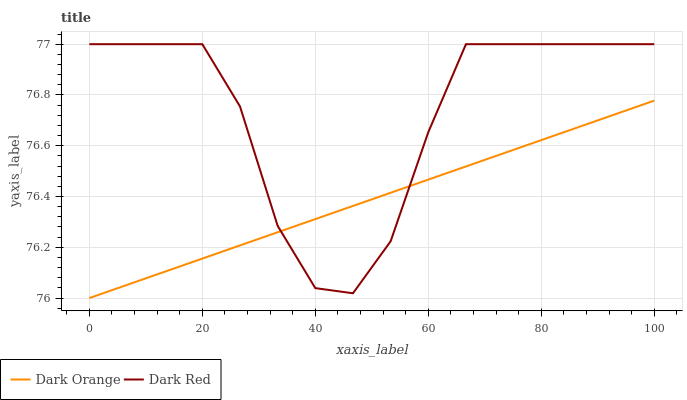Does Dark Orange have the minimum area under the curve?
Answer yes or no. Yes. Does Dark Red have the maximum area under the curve?
Answer yes or no. Yes. Does Dark Red have the minimum area under the curve?
Answer yes or no. No. Is Dark Orange the smoothest?
Answer yes or no. Yes. Is Dark Red the roughest?
Answer yes or no. Yes. Is Dark Red the smoothest?
Answer yes or no. No. Does Dark Orange have the lowest value?
Answer yes or no. Yes. Does Dark Red have the lowest value?
Answer yes or no. No. Does Dark Red have the highest value?
Answer yes or no. Yes. Does Dark Orange intersect Dark Red?
Answer yes or no. Yes. Is Dark Orange less than Dark Red?
Answer yes or no. No. Is Dark Orange greater than Dark Red?
Answer yes or no. No. 